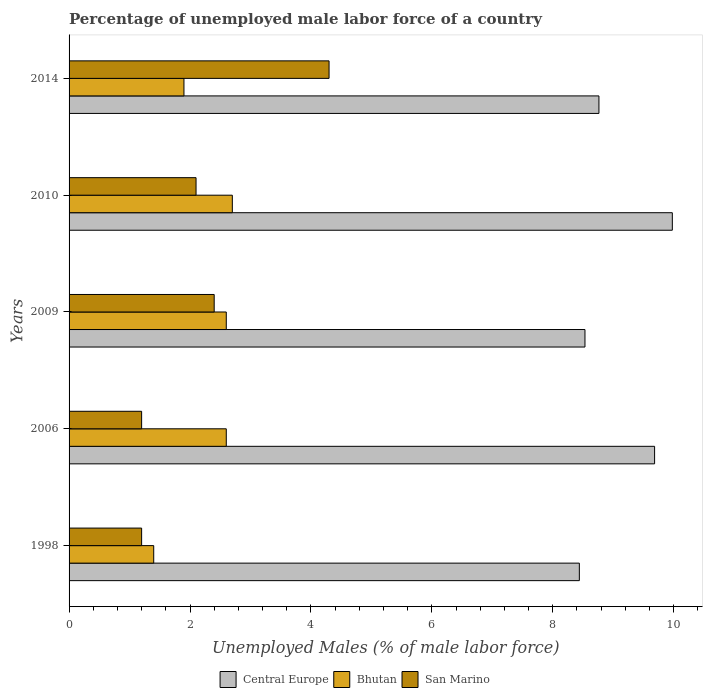How many different coloured bars are there?
Make the answer very short. 3. Are the number of bars per tick equal to the number of legend labels?
Give a very brief answer. Yes. Are the number of bars on each tick of the Y-axis equal?
Provide a short and direct response. Yes. How many bars are there on the 1st tick from the top?
Provide a succinct answer. 3. How many bars are there on the 2nd tick from the bottom?
Make the answer very short. 3. What is the label of the 3rd group of bars from the top?
Your response must be concise. 2009. In how many cases, is the number of bars for a given year not equal to the number of legend labels?
Make the answer very short. 0. What is the percentage of unemployed male labor force in Central Europe in 2006?
Ensure brevity in your answer.  9.68. Across all years, what is the maximum percentage of unemployed male labor force in Central Europe?
Offer a very short reply. 9.98. Across all years, what is the minimum percentage of unemployed male labor force in San Marino?
Your response must be concise. 1.2. What is the total percentage of unemployed male labor force in Bhutan in the graph?
Provide a short and direct response. 11.2. What is the difference between the percentage of unemployed male labor force in Central Europe in 2006 and that in 2009?
Your answer should be compact. 1.15. What is the difference between the percentage of unemployed male labor force in San Marino in 2010 and the percentage of unemployed male labor force in Central Europe in 2014?
Ensure brevity in your answer.  -6.66. What is the average percentage of unemployed male labor force in Bhutan per year?
Your response must be concise. 2.24. In the year 2009, what is the difference between the percentage of unemployed male labor force in San Marino and percentage of unemployed male labor force in Central Europe?
Provide a succinct answer. -6.13. What is the ratio of the percentage of unemployed male labor force in San Marino in 1998 to that in 2010?
Give a very brief answer. 0.57. What is the difference between the highest and the second highest percentage of unemployed male labor force in Bhutan?
Offer a very short reply. 0.1. What is the difference between the highest and the lowest percentage of unemployed male labor force in San Marino?
Offer a very short reply. 3.1. Is the sum of the percentage of unemployed male labor force in Central Europe in 2006 and 2014 greater than the maximum percentage of unemployed male labor force in San Marino across all years?
Your answer should be compact. Yes. What does the 1st bar from the top in 2010 represents?
Ensure brevity in your answer.  San Marino. What does the 1st bar from the bottom in 2014 represents?
Keep it short and to the point. Central Europe. Are all the bars in the graph horizontal?
Give a very brief answer. Yes. What is the difference between two consecutive major ticks on the X-axis?
Give a very brief answer. 2. Are the values on the major ticks of X-axis written in scientific E-notation?
Make the answer very short. No. Does the graph contain grids?
Give a very brief answer. No. Where does the legend appear in the graph?
Make the answer very short. Bottom center. How many legend labels are there?
Offer a very short reply. 3. What is the title of the graph?
Your answer should be compact. Percentage of unemployed male labor force of a country. Does "Europe(all income levels)" appear as one of the legend labels in the graph?
Your answer should be compact. No. What is the label or title of the X-axis?
Your answer should be compact. Unemployed Males (% of male labor force). What is the label or title of the Y-axis?
Your response must be concise. Years. What is the Unemployed Males (% of male labor force) of Central Europe in 1998?
Your answer should be compact. 8.44. What is the Unemployed Males (% of male labor force) of Bhutan in 1998?
Offer a terse response. 1.4. What is the Unemployed Males (% of male labor force) of San Marino in 1998?
Offer a terse response. 1.2. What is the Unemployed Males (% of male labor force) in Central Europe in 2006?
Your answer should be very brief. 9.68. What is the Unemployed Males (% of male labor force) in Bhutan in 2006?
Offer a very short reply. 2.6. What is the Unemployed Males (% of male labor force) in San Marino in 2006?
Offer a very short reply. 1.2. What is the Unemployed Males (% of male labor force) in Central Europe in 2009?
Your response must be concise. 8.53. What is the Unemployed Males (% of male labor force) in Bhutan in 2009?
Provide a succinct answer. 2.6. What is the Unemployed Males (% of male labor force) of San Marino in 2009?
Keep it short and to the point. 2.4. What is the Unemployed Males (% of male labor force) of Central Europe in 2010?
Make the answer very short. 9.98. What is the Unemployed Males (% of male labor force) of Bhutan in 2010?
Give a very brief answer. 2.7. What is the Unemployed Males (% of male labor force) in San Marino in 2010?
Your answer should be very brief. 2.1. What is the Unemployed Males (% of male labor force) of Central Europe in 2014?
Your response must be concise. 8.76. What is the Unemployed Males (% of male labor force) in Bhutan in 2014?
Provide a short and direct response. 1.9. What is the Unemployed Males (% of male labor force) in San Marino in 2014?
Keep it short and to the point. 4.3. Across all years, what is the maximum Unemployed Males (% of male labor force) in Central Europe?
Keep it short and to the point. 9.98. Across all years, what is the maximum Unemployed Males (% of male labor force) of Bhutan?
Your response must be concise. 2.7. Across all years, what is the maximum Unemployed Males (% of male labor force) of San Marino?
Your answer should be very brief. 4.3. Across all years, what is the minimum Unemployed Males (% of male labor force) in Central Europe?
Provide a succinct answer. 8.44. Across all years, what is the minimum Unemployed Males (% of male labor force) of Bhutan?
Provide a succinct answer. 1.4. Across all years, what is the minimum Unemployed Males (% of male labor force) of San Marino?
Provide a succinct answer. 1.2. What is the total Unemployed Males (% of male labor force) of Central Europe in the graph?
Your response must be concise. 45.4. What is the total Unemployed Males (% of male labor force) of Bhutan in the graph?
Your answer should be very brief. 11.2. What is the total Unemployed Males (% of male labor force) of San Marino in the graph?
Provide a succinct answer. 11.2. What is the difference between the Unemployed Males (% of male labor force) of Central Europe in 1998 and that in 2006?
Offer a very short reply. -1.24. What is the difference between the Unemployed Males (% of male labor force) of Bhutan in 1998 and that in 2006?
Offer a terse response. -1.2. What is the difference between the Unemployed Males (% of male labor force) of San Marino in 1998 and that in 2006?
Your answer should be very brief. 0. What is the difference between the Unemployed Males (% of male labor force) of Central Europe in 1998 and that in 2009?
Offer a very short reply. -0.09. What is the difference between the Unemployed Males (% of male labor force) of San Marino in 1998 and that in 2009?
Keep it short and to the point. -1.2. What is the difference between the Unemployed Males (% of male labor force) of Central Europe in 1998 and that in 2010?
Make the answer very short. -1.54. What is the difference between the Unemployed Males (% of male labor force) of Bhutan in 1998 and that in 2010?
Make the answer very short. -1.3. What is the difference between the Unemployed Males (% of male labor force) of San Marino in 1998 and that in 2010?
Your answer should be very brief. -0.9. What is the difference between the Unemployed Males (% of male labor force) in Central Europe in 1998 and that in 2014?
Provide a short and direct response. -0.32. What is the difference between the Unemployed Males (% of male labor force) of Central Europe in 2006 and that in 2009?
Your answer should be very brief. 1.15. What is the difference between the Unemployed Males (% of male labor force) of Bhutan in 2006 and that in 2009?
Your answer should be compact. 0. What is the difference between the Unemployed Males (% of male labor force) in San Marino in 2006 and that in 2009?
Give a very brief answer. -1.2. What is the difference between the Unemployed Males (% of male labor force) in Central Europe in 2006 and that in 2010?
Give a very brief answer. -0.29. What is the difference between the Unemployed Males (% of male labor force) in Central Europe in 2006 and that in 2014?
Ensure brevity in your answer.  0.92. What is the difference between the Unemployed Males (% of male labor force) in Bhutan in 2006 and that in 2014?
Your answer should be very brief. 0.7. What is the difference between the Unemployed Males (% of male labor force) in San Marino in 2006 and that in 2014?
Keep it short and to the point. -3.1. What is the difference between the Unemployed Males (% of male labor force) of Central Europe in 2009 and that in 2010?
Offer a terse response. -1.44. What is the difference between the Unemployed Males (% of male labor force) of San Marino in 2009 and that in 2010?
Give a very brief answer. 0.3. What is the difference between the Unemployed Males (% of male labor force) in Central Europe in 2009 and that in 2014?
Your answer should be compact. -0.23. What is the difference between the Unemployed Males (% of male labor force) of Bhutan in 2009 and that in 2014?
Give a very brief answer. 0.7. What is the difference between the Unemployed Males (% of male labor force) in San Marino in 2009 and that in 2014?
Provide a short and direct response. -1.9. What is the difference between the Unemployed Males (% of male labor force) of Central Europe in 2010 and that in 2014?
Provide a short and direct response. 1.21. What is the difference between the Unemployed Males (% of male labor force) of Central Europe in 1998 and the Unemployed Males (% of male labor force) of Bhutan in 2006?
Offer a very short reply. 5.84. What is the difference between the Unemployed Males (% of male labor force) of Central Europe in 1998 and the Unemployed Males (% of male labor force) of San Marino in 2006?
Offer a very short reply. 7.24. What is the difference between the Unemployed Males (% of male labor force) in Central Europe in 1998 and the Unemployed Males (% of male labor force) in Bhutan in 2009?
Ensure brevity in your answer.  5.84. What is the difference between the Unemployed Males (% of male labor force) of Central Europe in 1998 and the Unemployed Males (% of male labor force) of San Marino in 2009?
Ensure brevity in your answer.  6.04. What is the difference between the Unemployed Males (% of male labor force) in Bhutan in 1998 and the Unemployed Males (% of male labor force) in San Marino in 2009?
Make the answer very short. -1. What is the difference between the Unemployed Males (% of male labor force) in Central Europe in 1998 and the Unemployed Males (% of male labor force) in Bhutan in 2010?
Offer a very short reply. 5.74. What is the difference between the Unemployed Males (% of male labor force) in Central Europe in 1998 and the Unemployed Males (% of male labor force) in San Marino in 2010?
Give a very brief answer. 6.34. What is the difference between the Unemployed Males (% of male labor force) of Central Europe in 1998 and the Unemployed Males (% of male labor force) of Bhutan in 2014?
Offer a very short reply. 6.54. What is the difference between the Unemployed Males (% of male labor force) of Central Europe in 1998 and the Unemployed Males (% of male labor force) of San Marino in 2014?
Offer a terse response. 4.14. What is the difference between the Unemployed Males (% of male labor force) of Bhutan in 1998 and the Unemployed Males (% of male labor force) of San Marino in 2014?
Offer a terse response. -2.9. What is the difference between the Unemployed Males (% of male labor force) of Central Europe in 2006 and the Unemployed Males (% of male labor force) of Bhutan in 2009?
Your response must be concise. 7.08. What is the difference between the Unemployed Males (% of male labor force) of Central Europe in 2006 and the Unemployed Males (% of male labor force) of San Marino in 2009?
Your answer should be very brief. 7.28. What is the difference between the Unemployed Males (% of male labor force) in Bhutan in 2006 and the Unemployed Males (% of male labor force) in San Marino in 2009?
Provide a short and direct response. 0.2. What is the difference between the Unemployed Males (% of male labor force) in Central Europe in 2006 and the Unemployed Males (% of male labor force) in Bhutan in 2010?
Give a very brief answer. 6.98. What is the difference between the Unemployed Males (% of male labor force) of Central Europe in 2006 and the Unemployed Males (% of male labor force) of San Marino in 2010?
Make the answer very short. 7.58. What is the difference between the Unemployed Males (% of male labor force) in Central Europe in 2006 and the Unemployed Males (% of male labor force) in Bhutan in 2014?
Make the answer very short. 7.78. What is the difference between the Unemployed Males (% of male labor force) of Central Europe in 2006 and the Unemployed Males (% of male labor force) of San Marino in 2014?
Keep it short and to the point. 5.38. What is the difference between the Unemployed Males (% of male labor force) in Central Europe in 2009 and the Unemployed Males (% of male labor force) in Bhutan in 2010?
Offer a terse response. 5.83. What is the difference between the Unemployed Males (% of male labor force) in Central Europe in 2009 and the Unemployed Males (% of male labor force) in San Marino in 2010?
Make the answer very short. 6.43. What is the difference between the Unemployed Males (% of male labor force) in Central Europe in 2009 and the Unemployed Males (% of male labor force) in Bhutan in 2014?
Offer a terse response. 6.63. What is the difference between the Unemployed Males (% of male labor force) in Central Europe in 2009 and the Unemployed Males (% of male labor force) in San Marino in 2014?
Offer a very short reply. 4.23. What is the difference between the Unemployed Males (% of male labor force) of Central Europe in 2010 and the Unemployed Males (% of male labor force) of Bhutan in 2014?
Offer a terse response. 8.08. What is the difference between the Unemployed Males (% of male labor force) in Central Europe in 2010 and the Unemployed Males (% of male labor force) in San Marino in 2014?
Keep it short and to the point. 5.68. What is the average Unemployed Males (% of male labor force) in Central Europe per year?
Make the answer very short. 9.08. What is the average Unemployed Males (% of male labor force) of Bhutan per year?
Ensure brevity in your answer.  2.24. What is the average Unemployed Males (% of male labor force) of San Marino per year?
Provide a succinct answer. 2.24. In the year 1998, what is the difference between the Unemployed Males (% of male labor force) of Central Europe and Unemployed Males (% of male labor force) of Bhutan?
Make the answer very short. 7.04. In the year 1998, what is the difference between the Unemployed Males (% of male labor force) of Central Europe and Unemployed Males (% of male labor force) of San Marino?
Give a very brief answer. 7.24. In the year 1998, what is the difference between the Unemployed Males (% of male labor force) of Bhutan and Unemployed Males (% of male labor force) of San Marino?
Make the answer very short. 0.2. In the year 2006, what is the difference between the Unemployed Males (% of male labor force) in Central Europe and Unemployed Males (% of male labor force) in Bhutan?
Provide a short and direct response. 7.08. In the year 2006, what is the difference between the Unemployed Males (% of male labor force) of Central Europe and Unemployed Males (% of male labor force) of San Marino?
Make the answer very short. 8.48. In the year 2009, what is the difference between the Unemployed Males (% of male labor force) in Central Europe and Unemployed Males (% of male labor force) in Bhutan?
Provide a short and direct response. 5.93. In the year 2009, what is the difference between the Unemployed Males (% of male labor force) in Central Europe and Unemployed Males (% of male labor force) in San Marino?
Provide a short and direct response. 6.13. In the year 2009, what is the difference between the Unemployed Males (% of male labor force) in Bhutan and Unemployed Males (% of male labor force) in San Marino?
Offer a very short reply. 0.2. In the year 2010, what is the difference between the Unemployed Males (% of male labor force) in Central Europe and Unemployed Males (% of male labor force) in Bhutan?
Offer a very short reply. 7.28. In the year 2010, what is the difference between the Unemployed Males (% of male labor force) in Central Europe and Unemployed Males (% of male labor force) in San Marino?
Keep it short and to the point. 7.88. In the year 2014, what is the difference between the Unemployed Males (% of male labor force) in Central Europe and Unemployed Males (% of male labor force) in Bhutan?
Your answer should be compact. 6.86. In the year 2014, what is the difference between the Unemployed Males (% of male labor force) in Central Europe and Unemployed Males (% of male labor force) in San Marino?
Give a very brief answer. 4.46. In the year 2014, what is the difference between the Unemployed Males (% of male labor force) of Bhutan and Unemployed Males (% of male labor force) of San Marino?
Provide a short and direct response. -2.4. What is the ratio of the Unemployed Males (% of male labor force) of Central Europe in 1998 to that in 2006?
Your answer should be compact. 0.87. What is the ratio of the Unemployed Males (% of male labor force) in Bhutan in 1998 to that in 2006?
Offer a terse response. 0.54. What is the ratio of the Unemployed Males (% of male labor force) of Central Europe in 1998 to that in 2009?
Provide a short and direct response. 0.99. What is the ratio of the Unemployed Males (% of male labor force) of Bhutan in 1998 to that in 2009?
Provide a succinct answer. 0.54. What is the ratio of the Unemployed Males (% of male labor force) of San Marino in 1998 to that in 2009?
Give a very brief answer. 0.5. What is the ratio of the Unemployed Males (% of male labor force) of Central Europe in 1998 to that in 2010?
Give a very brief answer. 0.85. What is the ratio of the Unemployed Males (% of male labor force) of Bhutan in 1998 to that in 2010?
Provide a succinct answer. 0.52. What is the ratio of the Unemployed Males (% of male labor force) of Central Europe in 1998 to that in 2014?
Offer a terse response. 0.96. What is the ratio of the Unemployed Males (% of male labor force) of Bhutan in 1998 to that in 2014?
Give a very brief answer. 0.74. What is the ratio of the Unemployed Males (% of male labor force) of San Marino in 1998 to that in 2014?
Your answer should be very brief. 0.28. What is the ratio of the Unemployed Males (% of male labor force) in Central Europe in 2006 to that in 2009?
Make the answer very short. 1.14. What is the ratio of the Unemployed Males (% of male labor force) in Central Europe in 2006 to that in 2010?
Offer a very short reply. 0.97. What is the ratio of the Unemployed Males (% of male labor force) of Bhutan in 2006 to that in 2010?
Provide a short and direct response. 0.96. What is the ratio of the Unemployed Males (% of male labor force) in Central Europe in 2006 to that in 2014?
Make the answer very short. 1.1. What is the ratio of the Unemployed Males (% of male labor force) of Bhutan in 2006 to that in 2014?
Your response must be concise. 1.37. What is the ratio of the Unemployed Males (% of male labor force) in San Marino in 2006 to that in 2014?
Your answer should be compact. 0.28. What is the ratio of the Unemployed Males (% of male labor force) of Central Europe in 2009 to that in 2010?
Keep it short and to the point. 0.86. What is the ratio of the Unemployed Males (% of male labor force) of Bhutan in 2009 to that in 2010?
Give a very brief answer. 0.96. What is the ratio of the Unemployed Males (% of male labor force) of San Marino in 2009 to that in 2010?
Your response must be concise. 1.14. What is the ratio of the Unemployed Males (% of male labor force) of Central Europe in 2009 to that in 2014?
Offer a very short reply. 0.97. What is the ratio of the Unemployed Males (% of male labor force) in Bhutan in 2009 to that in 2014?
Provide a short and direct response. 1.37. What is the ratio of the Unemployed Males (% of male labor force) of San Marino in 2009 to that in 2014?
Give a very brief answer. 0.56. What is the ratio of the Unemployed Males (% of male labor force) in Central Europe in 2010 to that in 2014?
Give a very brief answer. 1.14. What is the ratio of the Unemployed Males (% of male labor force) in Bhutan in 2010 to that in 2014?
Make the answer very short. 1.42. What is the ratio of the Unemployed Males (% of male labor force) in San Marino in 2010 to that in 2014?
Your response must be concise. 0.49. What is the difference between the highest and the second highest Unemployed Males (% of male labor force) of Central Europe?
Provide a short and direct response. 0.29. What is the difference between the highest and the second highest Unemployed Males (% of male labor force) in San Marino?
Give a very brief answer. 1.9. What is the difference between the highest and the lowest Unemployed Males (% of male labor force) of Central Europe?
Offer a terse response. 1.54. What is the difference between the highest and the lowest Unemployed Males (% of male labor force) of Bhutan?
Your answer should be compact. 1.3. What is the difference between the highest and the lowest Unemployed Males (% of male labor force) of San Marino?
Offer a terse response. 3.1. 